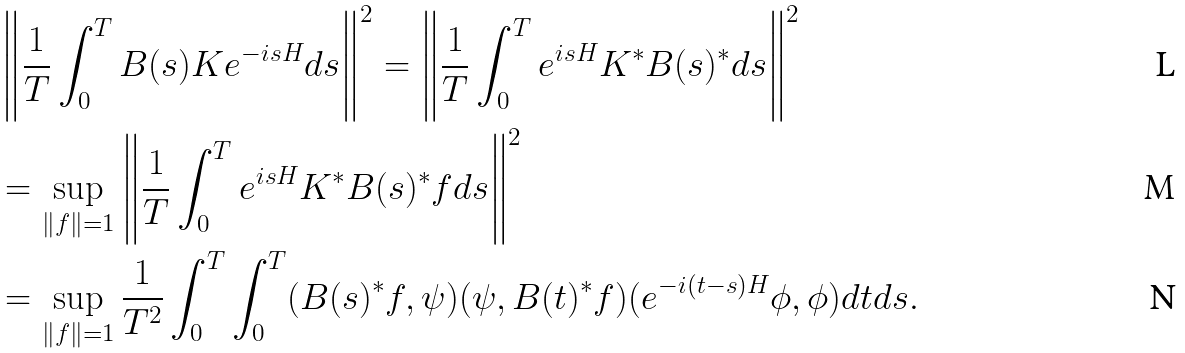Convert formula to latex. <formula><loc_0><loc_0><loc_500><loc_500>& \left \| \frac { 1 } { T } \int _ { 0 } ^ { T } B ( s ) K e ^ { - i s H } d s \right \| ^ { 2 } = \left \| \frac { 1 } { T } \int _ { 0 } ^ { T } e ^ { i s H } K ^ { * } B ( s ) ^ { * } d s \right \| ^ { 2 } \\ & = \sup _ { \| f \| = 1 } \left \| \frac { 1 } { T } \int _ { 0 } ^ { T } e ^ { i s H } K ^ { * } B ( s ) ^ { * } f d s \right \| ^ { 2 } \\ & = \sup _ { \| f \| = 1 } \frac { 1 } { T ^ { 2 } } \int _ { 0 } ^ { T } \int _ { 0 } ^ { T } ( B ( s ) ^ { * } f , \psi ) ( \psi , B ( t ) ^ { * } f ) ( e ^ { - i ( t - s ) H } \phi , \phi ) d t d s .</formula> 